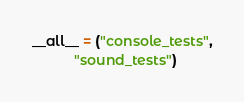Convert code to text. <code><loc_0><loc_0><loc_500><loc_500><_Python_>
__all__ = ("console_tests",
           "sound_tests")
</code> 